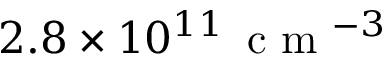<formula> <loc_0><loc_0><loc_500><loc_500>2 . 8 \times 1 0 ^ { 1 1 } \, c m ^ { - 3 }</formula> 